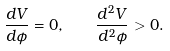<formula> <loc_0><loc_0><loc_500><loc_500>\frac { d V } { d \phi } = 0 , \quad \frac { d ^ { 2 } V } { d ^ { 2 } \phi } > 0 .</formula> 